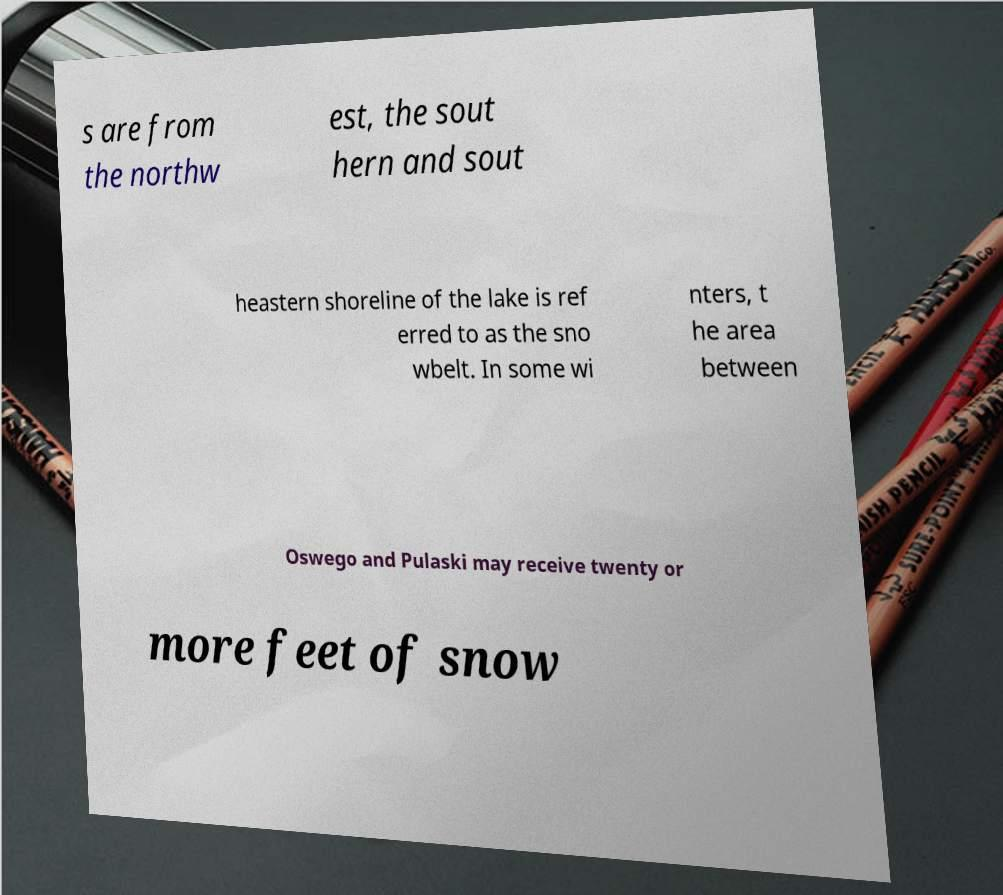What messages or text are displayed in this image? I need them in a readable, typed format. s are from the northw est, the sout hern and sout heastern shoreline of the lake is ref erred to as the sno wbelt. In some wi nters, t he area between Oswego and Pulaski may receive twenty or more feet of snow 